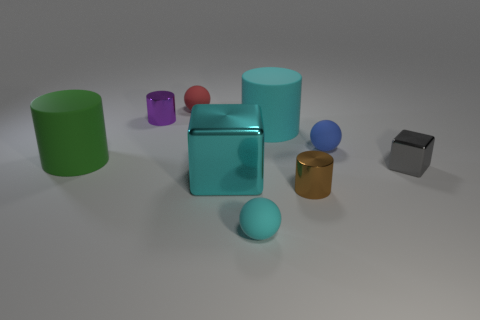There is a purple object that is the same material as the large cyan cube; what is its shape? cylinder 